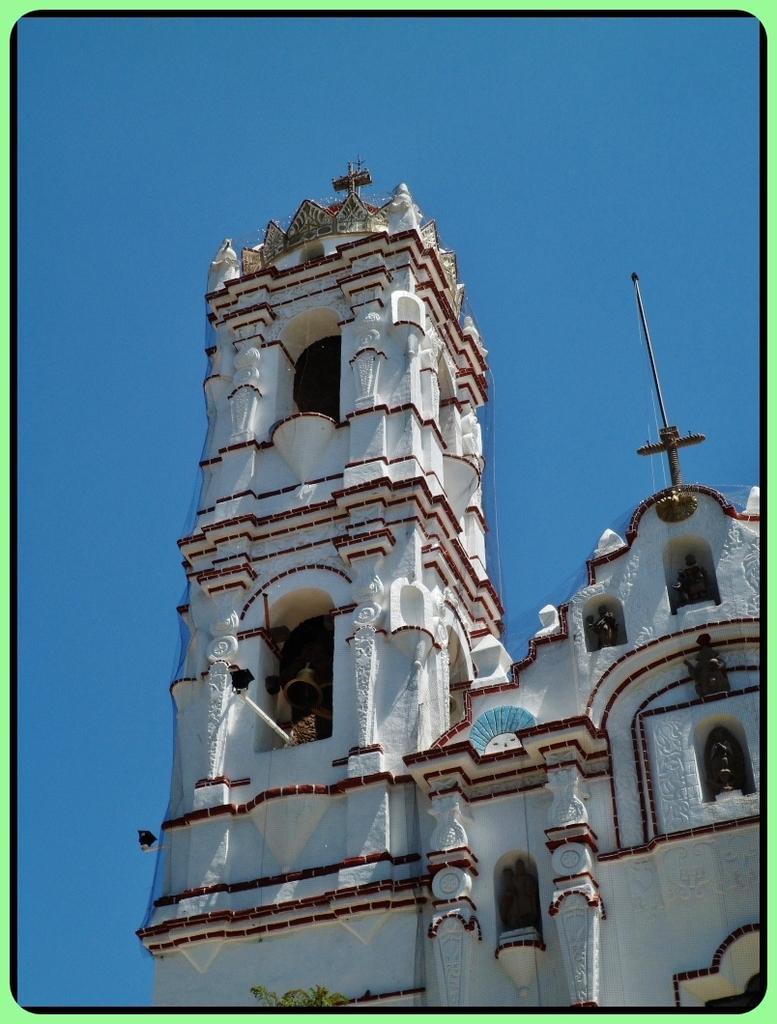How would you summarize this image in a sentence or two? In this picture we can see a building, bell, cross, statues and in the background we can see the sky. 